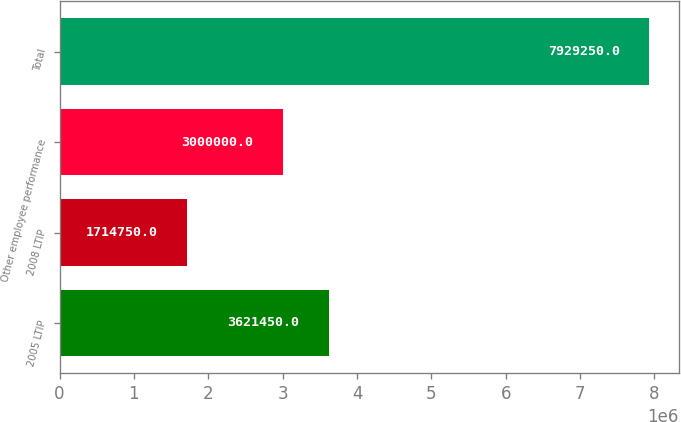Convert chart to OTSL. <chart><loc_0><loc_0><loc_500><loc_500><bar_chart><fcel>2005 LTIP<fcel>2008 LTIP<fcel>Other employee performance<fcel>Total<nl><fcel>3.62145e+06<fcel>1.71475e+06<fcel>3e+06<fcel>7.92925e+06<nl></chart> 